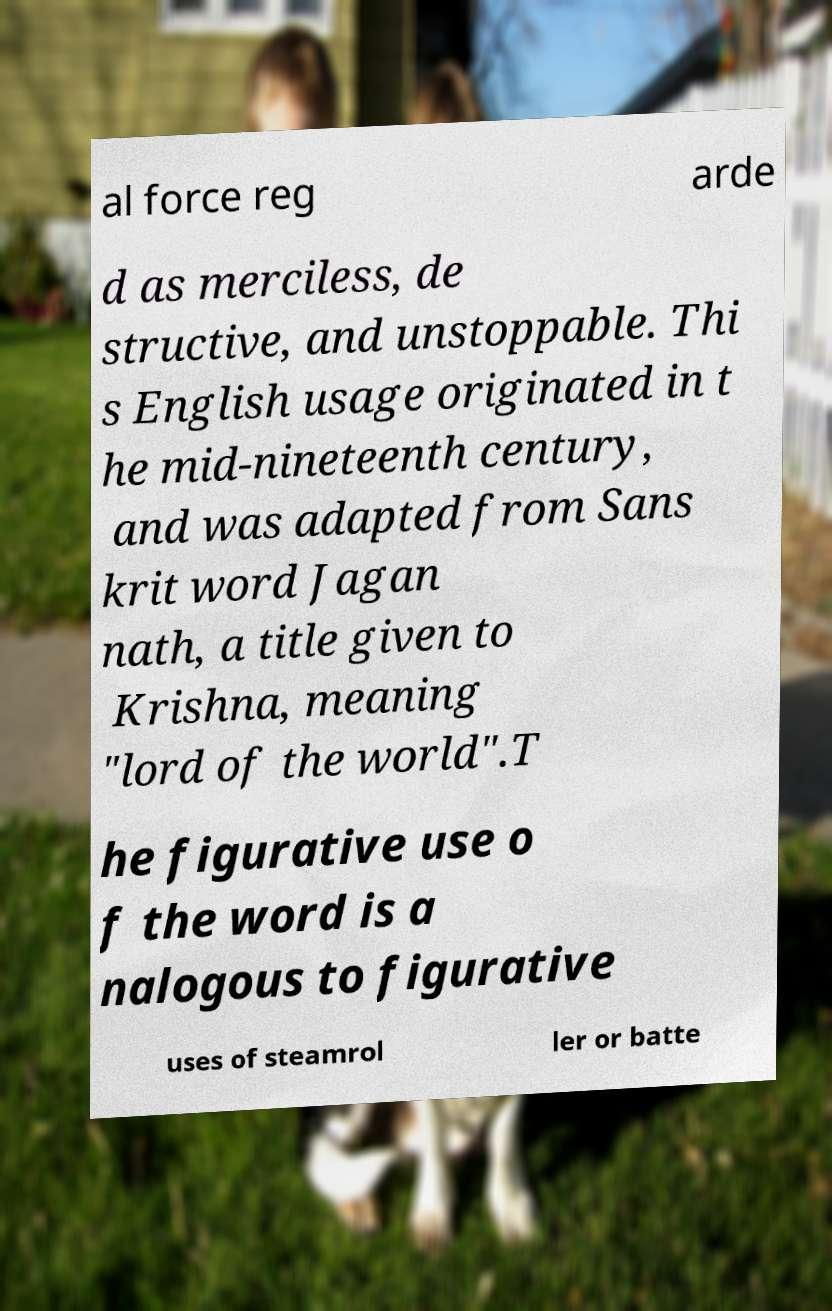Please read and relay the text visible in this image. What does it say? al force reg arde d as merciless, de structive, and unstoppable. Thi s English usage originated in t he mid-nineteenth century, and was adapted from Sans krit word Jagan nath, a title given to Krishna, meaning "lord of the world".T he figurative use o f the word is a nalogous to figurative uses of steamrol ler or batte 